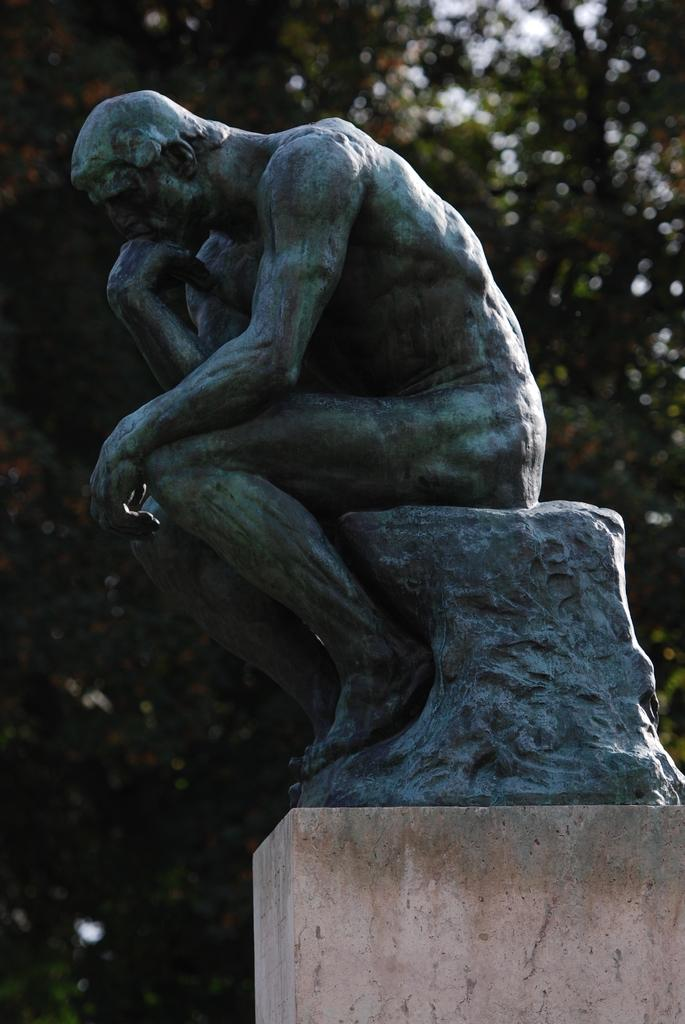What is the main subject of the image? The main subject of the image is a statue of a person sitting on a rock. Where is the statue located? The statue is on a rock. What can be seen at the bottom of the image? There is a basement at the bottom of the image. What is visible in the background of the image? There are trees in the background of the image. What type of joke is the statue telling in the image? The statue is not telling a joke in the image; it is a stationary sculpture. 